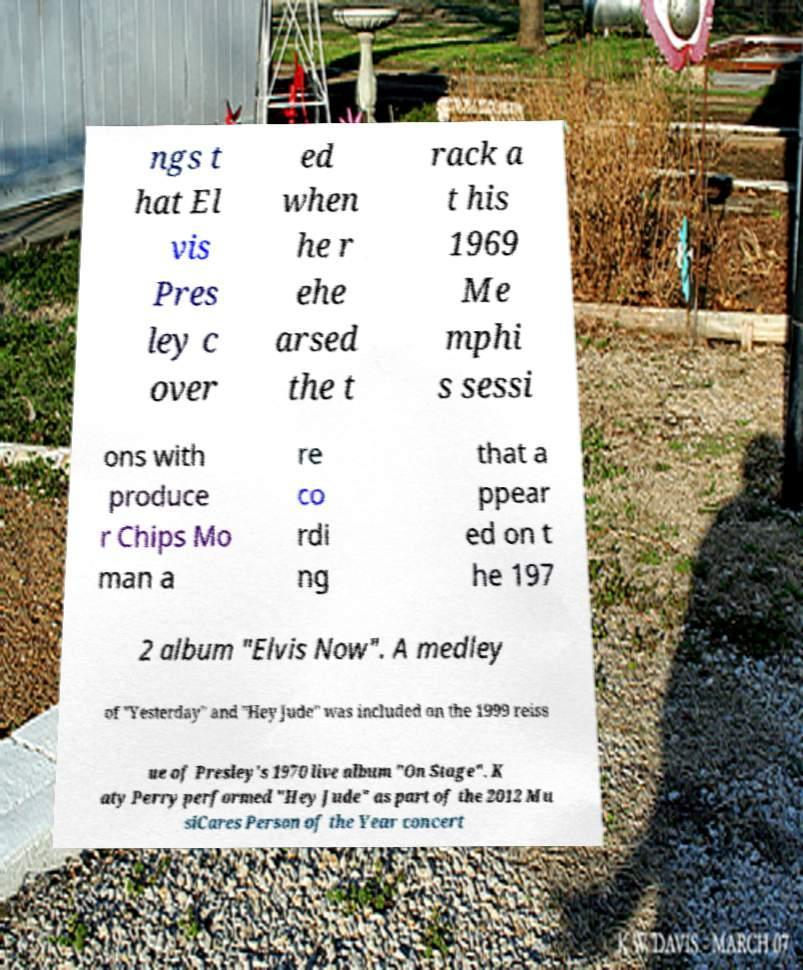What messages or text are displayed in this image? I need them in a readable, typed format. ngs t hat El vis Pres ley c over ed when he r ehe arsed the t rack a t his 1969 Me mphi s sessi ons with produce r Chips Mo man a re co rdi ng that a ppear ed on t he 197 2 album "Elvis Now". A medley of "Yesterday" and "Hey Jude" was included on the 1999 reiss ue of Presley's 1970 live album "On Stage". K aty Perry performed "Hey Jude" as part of the 2012 Mu siCares Person of the Year concert 